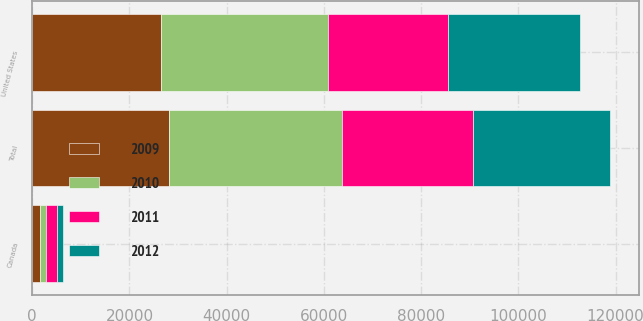Convert chart to OTSL. <chart><loc_0><loc_0><loc_500><loc_500><stacked_bar_chart><ecel><fcel>United States<fcel>Canada<fcel>Total<nl><fcel>2009<fcel>26500<fcel>1533<fcel>28033<nl><fcel>2012<fcel>27171<fcel>1207<fcel>28378<nl><fcel>2010<fcel>34391<fcel>1351<fcel>35742<nl><fcel>2011<fcel>24629<fcel>2161<fcel>26790<nl></chart> 